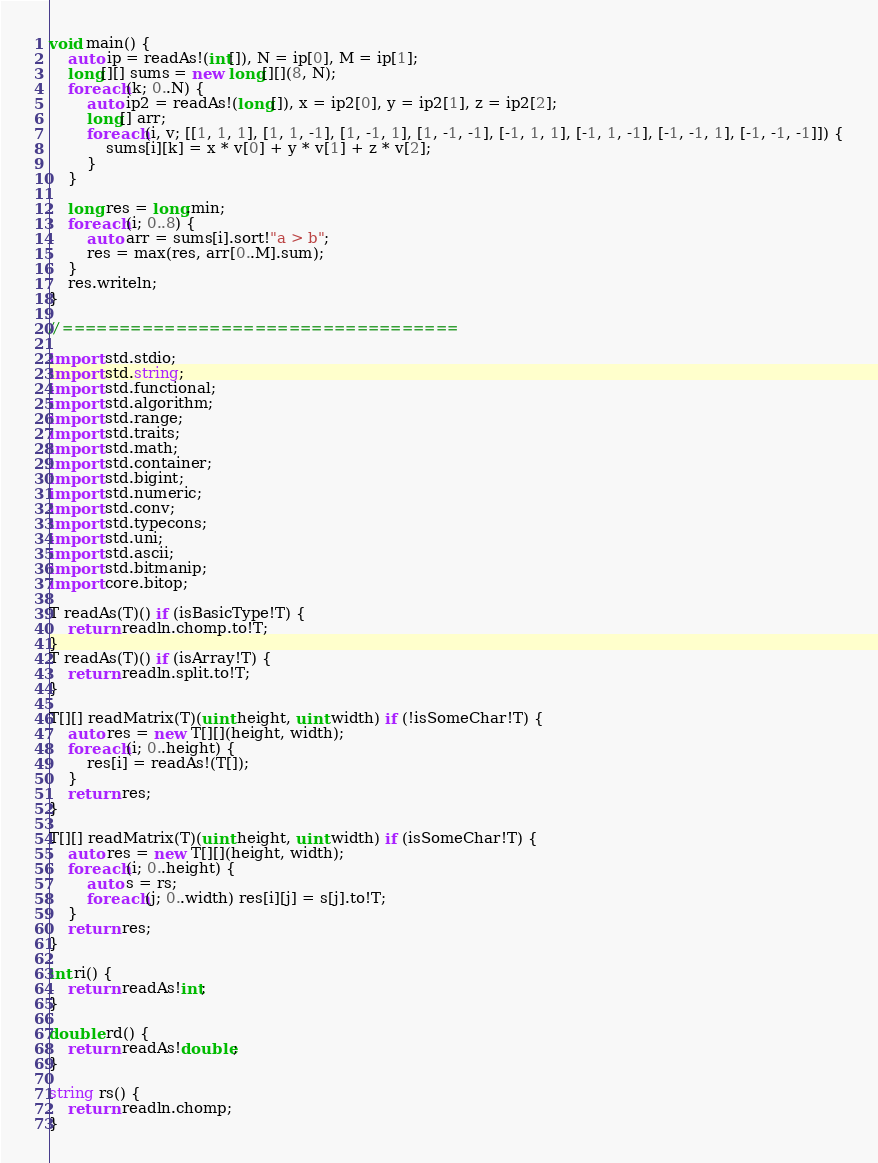Convert code to text. <code><loc_0><loc_0><loc_500><loc_500><_D_>void main() {
	auto ip = readAs!(int[]), N = ip[0], M = ip[1];
	long[][] sums = new long[][](8, N);
	foreach(k; 0..N) {
		auto ip2 = readAs!(long[]), x = ip2[0], y = ip2[1], z = ip2[2];
		long[] arr;
		foreach(i, v; [[1, 1, 1], [1, 1, -1], [1, -1, 1], [1, -1, -1], [-1, 1, 1], [-1, 1, -1], [-1, -1, 1], [-1, -1, -1]]) {
			sums[i][k] = x * v[0] + y * v[1] + z * v[2];
		}
	}
	
	long res = long.min;
	foreach(i; 0..8) {
		auto arr = sums[i].sort!"a > b";
		res = max(res, arr[0..M].sum);
	}
	res.writeln;
}

// ===================================

import std.stdio;
import std.string;
import std.functional;
import std.algorithm;
import std.range;
import std.traits;
import std.math;
import std.container;
import std.bigint;
import std.numeric;
import std.conv;
import std.typecons;
import std.uni;
import std.ascii;
import std.bitmanip;
import core.bitop;

T readAs(T)() if (isBasicType!T) {
	return readln.chomp.to!T;
}
T readAs(T)() if (isArray!T) {
	return readln.split.to!T;
}

T[][] readMatrix(T)(uint height, uint width) if (!isSomeChar!T) {
	auto res = new T[][](height, width);
	foreach(i; 0..height) {
		res[i] = readAs!(T[]);
	}
	return res;
}

T[][] readMatrix(T)(uint height, uint width) if (isSomeChar!T) {
	auto res = new T[][](height, width);
	foreach(i; 0..height) {
		auto s = rs;
		foreach(j; 0..width) res[i][j] = s[j].to!T;
	}
	return res;
}

int ri() {
	return readAs!int;
}

double rd() {
	return readAs!double;
}

string rs() {
	return readln.chomp;
}
</code> 